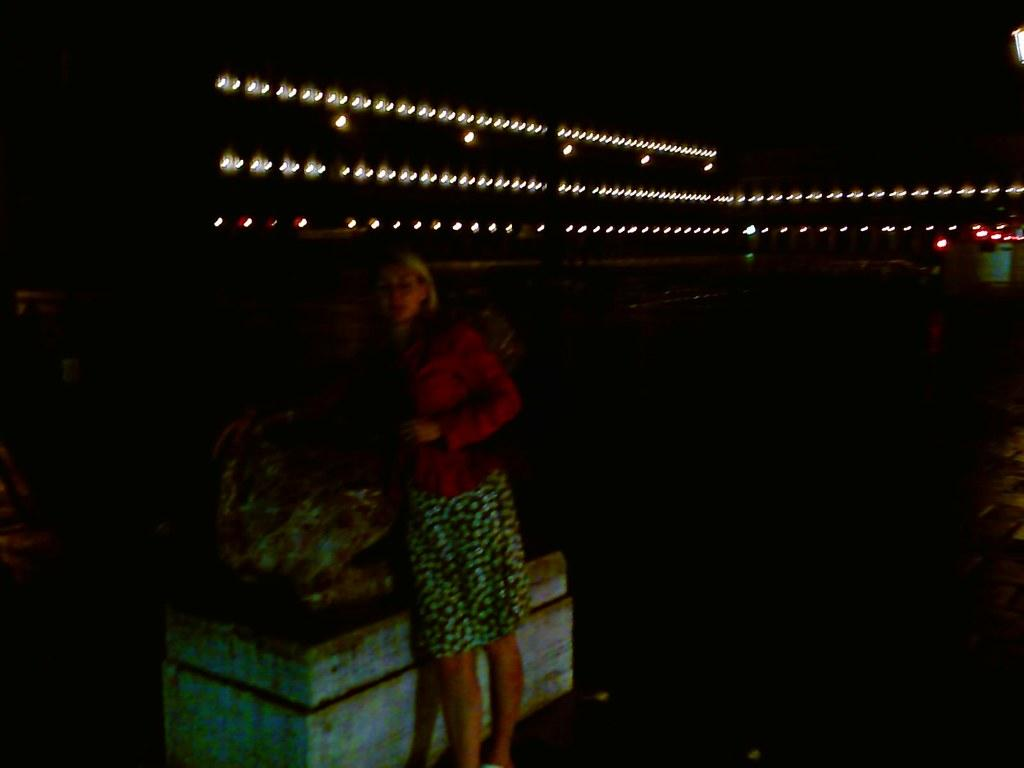What is the main subject of the image? There is a woman standing in the image. What can be seen on the wall in the image? There appears to be a sculpture on a wall in the image. What is visible in the background of the image? There are lights visible in the background of the image. What type of wool is being used to make the beds in the image? There are no beds present in the image, so it is not possible to determine what type of wool might be used for them. 